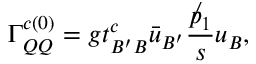Convert formula to latex. <formula><loc_0><loc_0><loc_500><loc_500>\Gamma _ { Q Q } ^ { c ( 0 ) } = g t _ { B ^ { \prime } B } ^ { c } \bar { u } _ { B ^ { \prime } } \frac { \not p _ { 1 } } { s } u _ { B } ,</formula> 